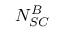Convert formula to latex. <formula><loc_0><loc_0><loc_500><loc_500>N _ { S C } ^ { B }</formula> 